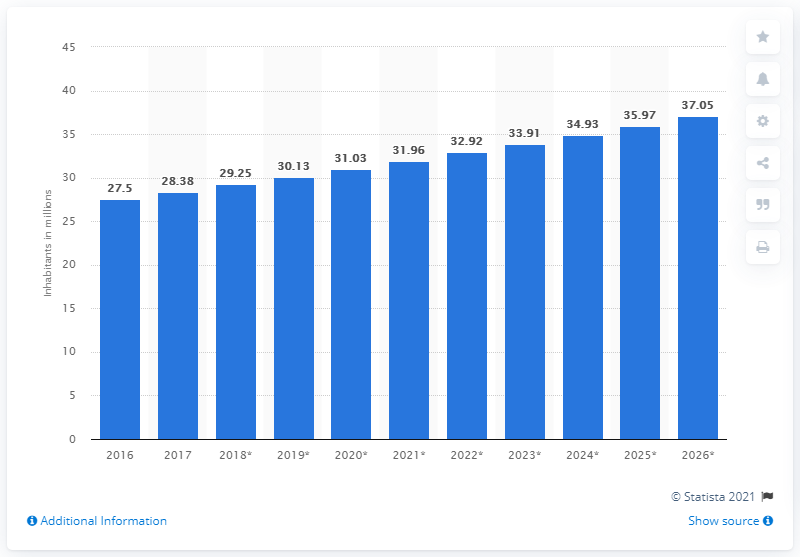Identify some key points in this picture. In 2017, the population of Angola was 28.38 million. 